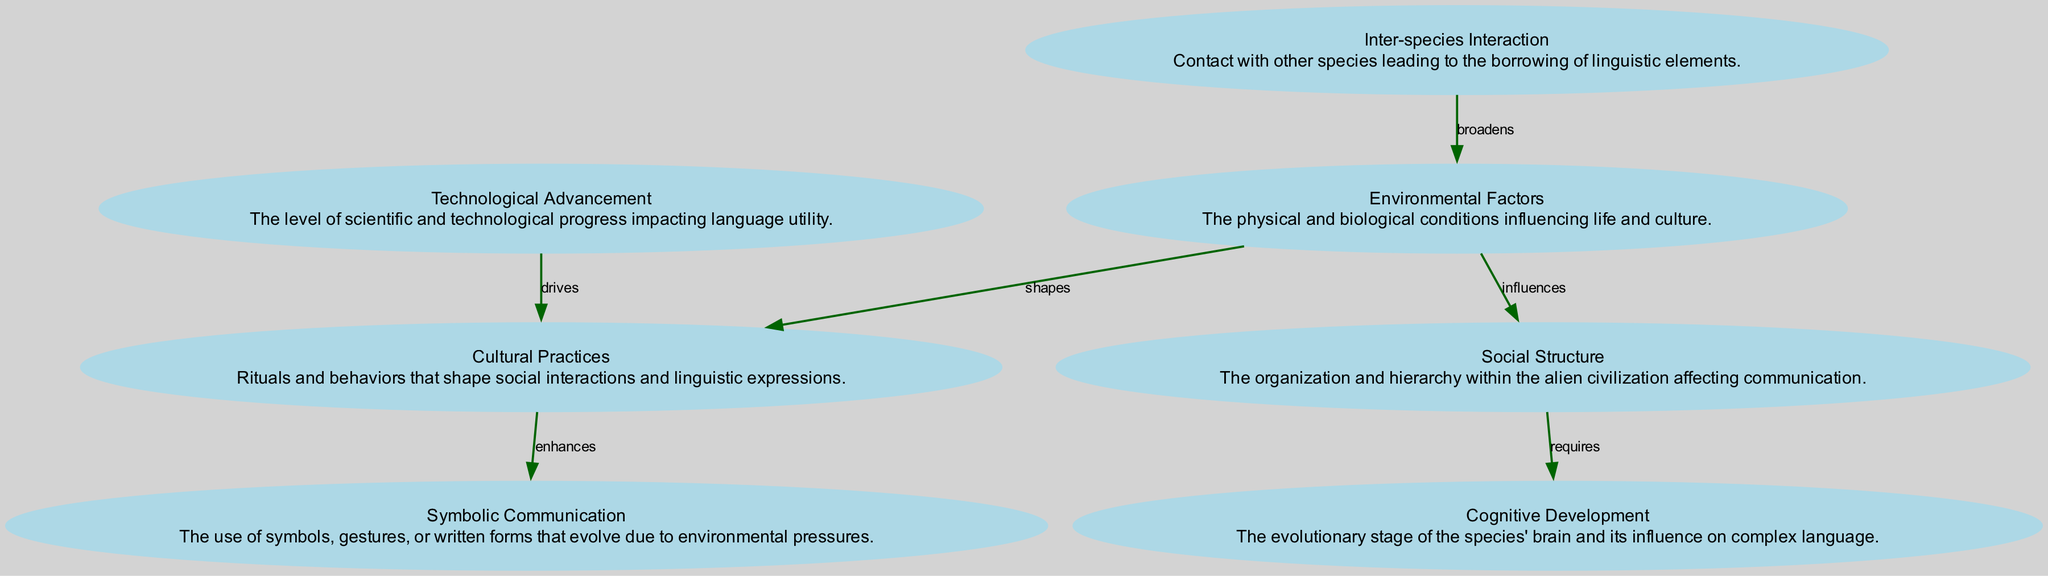What are the total number of nodes in the diagram? The diagram lists distinct elements or nodes. Counting them gives us a total of seven nodes: Environmental Factors, Social Structure, Cultural Practices, Technological Advancement, Symbolic Communication, Cognitive Development, and Inter-species Interaction.
Answer: 7 Which node influences Social Structure? According to the connections, the node labeled Environmental Factors has a direct link to Social Structure with the label "influences." This indicates that Environmental Factors impact or shape the Social Structure.
Answer: Environmental Factors What is the relationship between Cultural Practices and Symbolic Communication? The edge from Cultural Practices to Symbolic Communication is labeled "enhances," indicating that Cultural Practices enhance or improve the development of Symbolic Communication. This can be interpreted as richer cultural practices leading to more complex forms of symbolic expression.
Answer: enhances Which node is driven by Technological Advancement? The diagram shows a connection from Technological Advancement to Cultural Practices, labeled as "drives." This means that advancements in technology affect and promote the evolution of Cultural Practices within the civilization.
Answer: Cultural Practices What is the connection label between Inter-species Interaction and Environmental Factors? Looking at the directed edge from Inter-species Interaction to Environmental Factors, it is labeled "broadens." This indicates that interactions with other species expand or broaden the range of Environmental Factors influencing the alien civilization.
Answer: broadens How does Social Structure relate to Cognitive Development? There is an arrow from Social Structure to Cognitive Development with the label "requires." This suggests that the structure of the society necessitates certain levels of cognitive abilities for effective communication and interaction. Thus, a well-organized Social Structure relies on cognitive skills.
Answer: requires What environmental element shapes Cultural Practices? The relationships in the diagram indicate that Environmental Factors directly "shapes" Cultural Practices. This implies that the surrounding environment has a direct influence on how cultural practices are formed and evolved.
Answer: Environmental Factors 